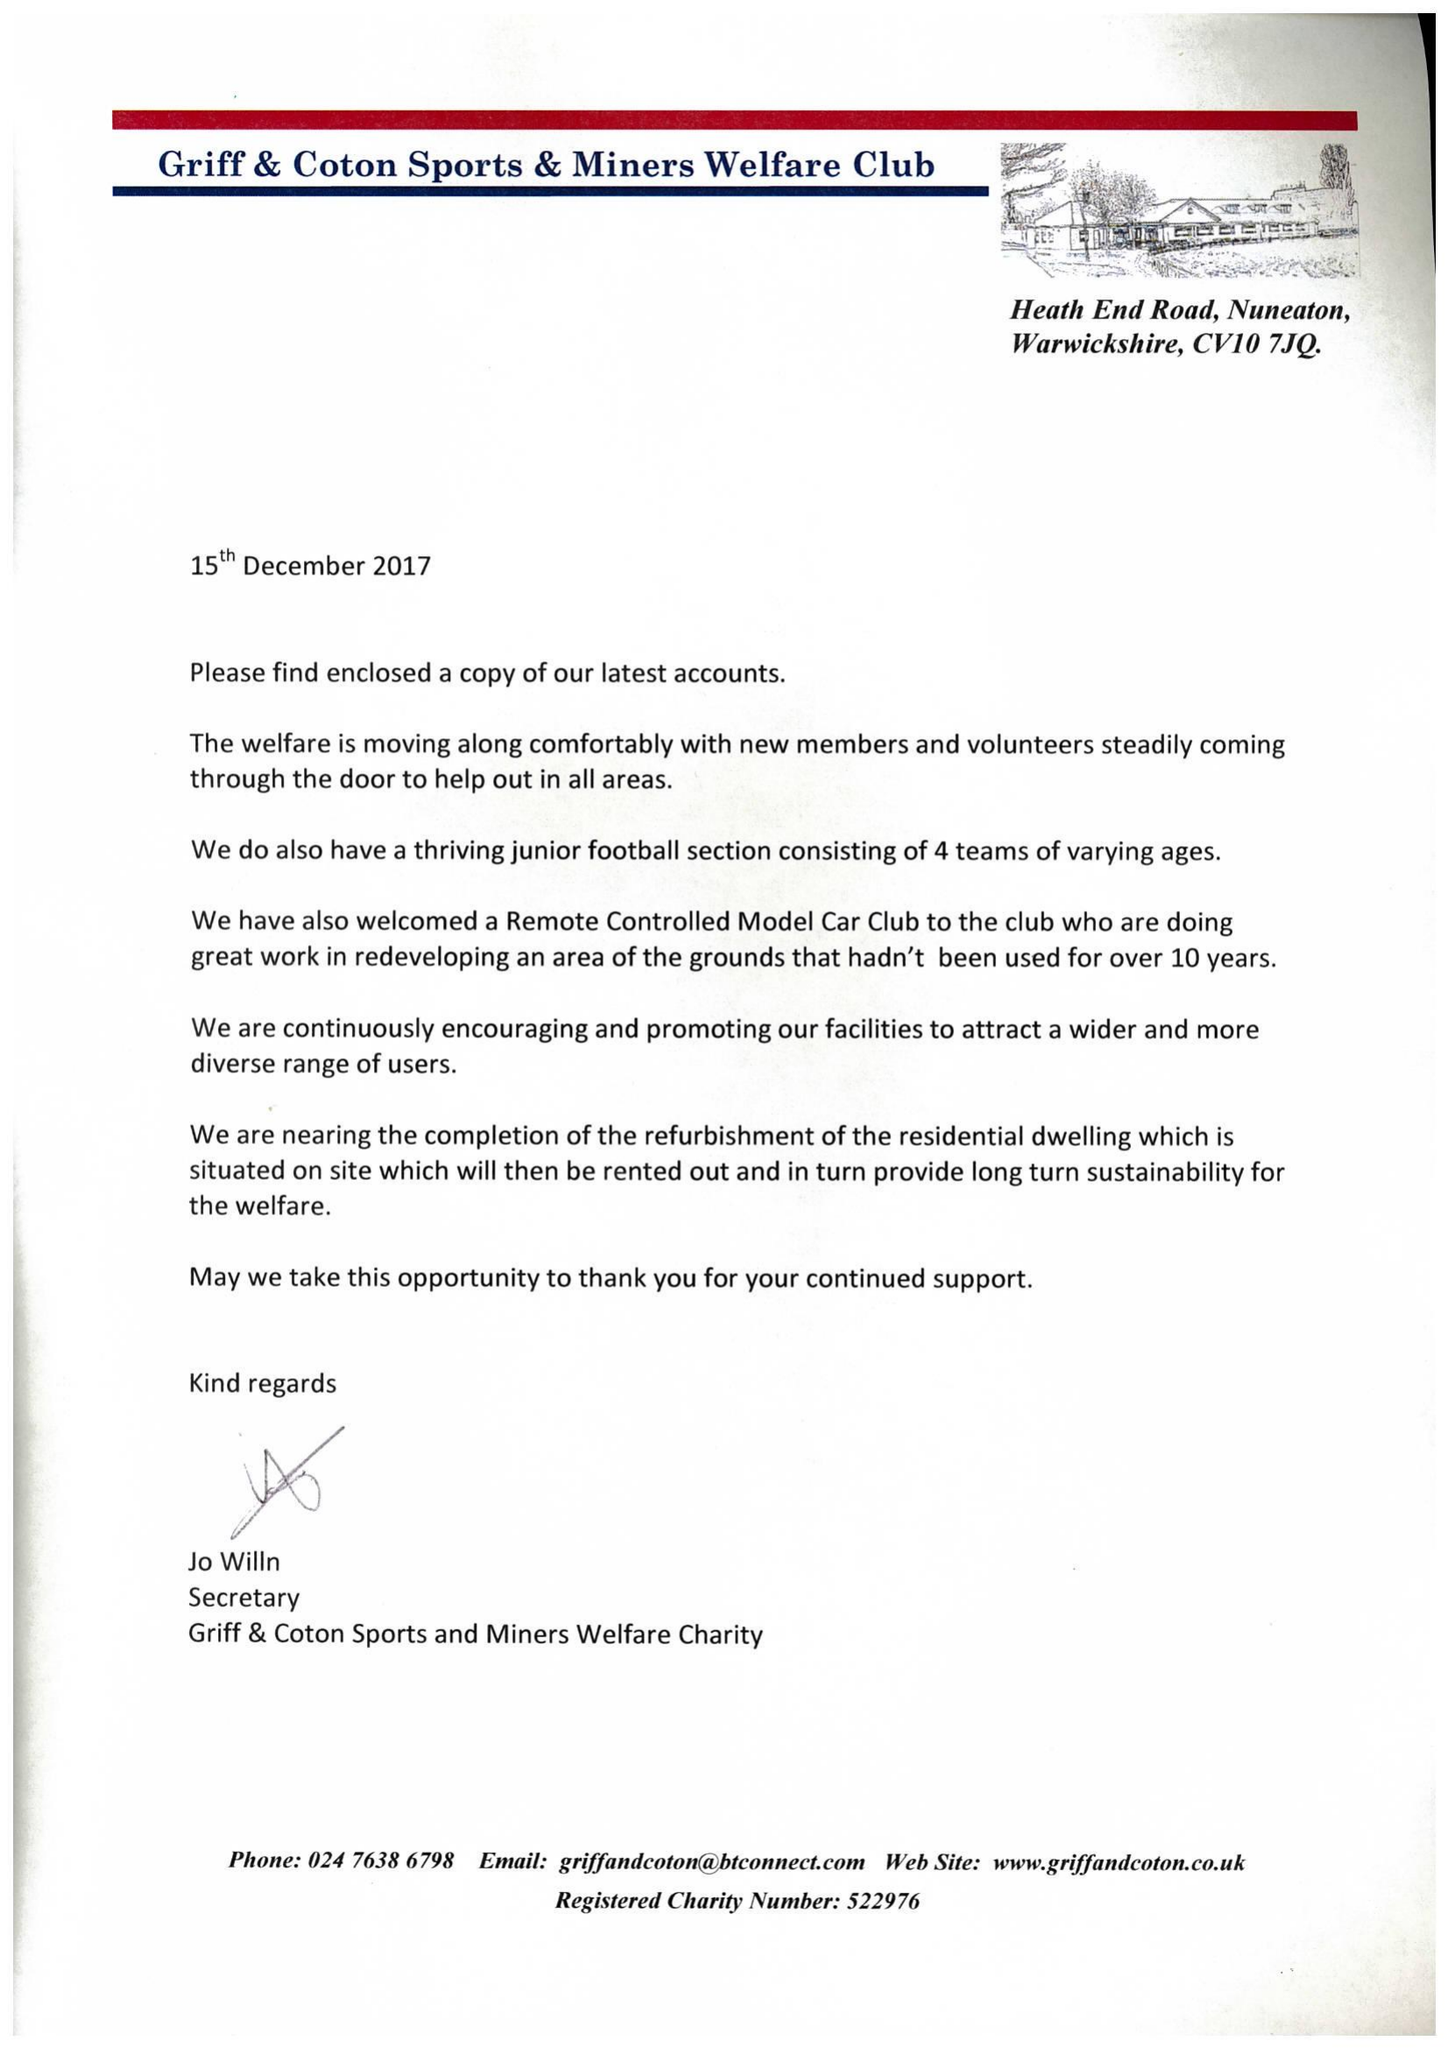What is the value for the charity_number?
Answer the question using a single word or phrase. 522976 